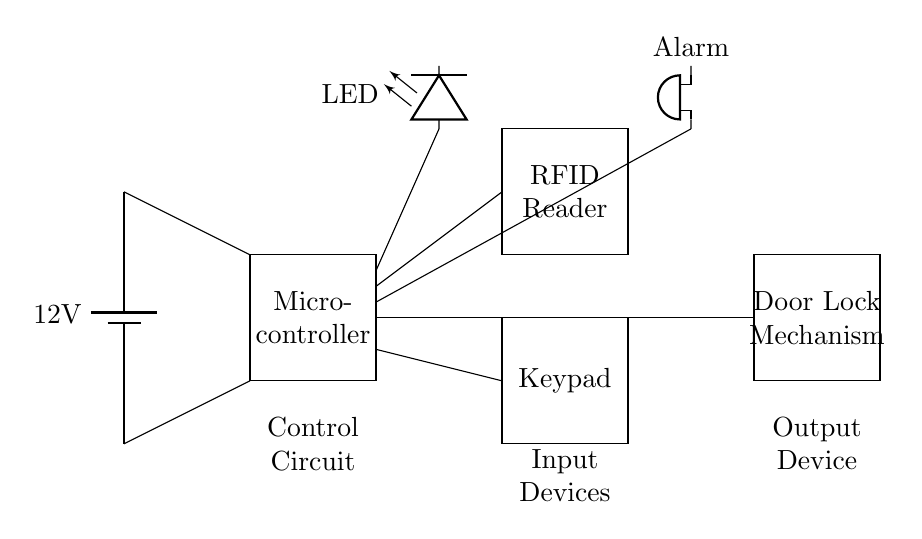What is the voltage of the power supply? The voltage of the power supply is indicated as 12 volts on the battery symbol in the circuit.
Answer: 12 volts What type of components are used for input? The input components in the circuit include an RFID reader and a keypad, which are specific devices designed for user access via credentials.
Answer: RFID reader, keypad What does the LED indicate in this circuit? The LED is typically used as a visual indicator to show the status of the system, such as successful access or operation of the circuit activities.
Answer: Status indicator How are the input devices connected to the control circuit? The RFID reader and keypad are connected to the microcontroller, which handles the input data processing and communication with the door lock mechanism.
Answer: Via microcontroller What triggers the alarm in this automated access control system? The alarm is triggered when unauthorized access is detected, indicated by the wiring from the microcontroller to the alarm device in the circuit.
Answer: Unauthorized access Which component controls the locking mechanism? The door lock mechanism is controlled by the microcontroller, allowing it to lock or unlock based on the inputs received from the RFID reader or keypad.
Answer: Microcontroller 